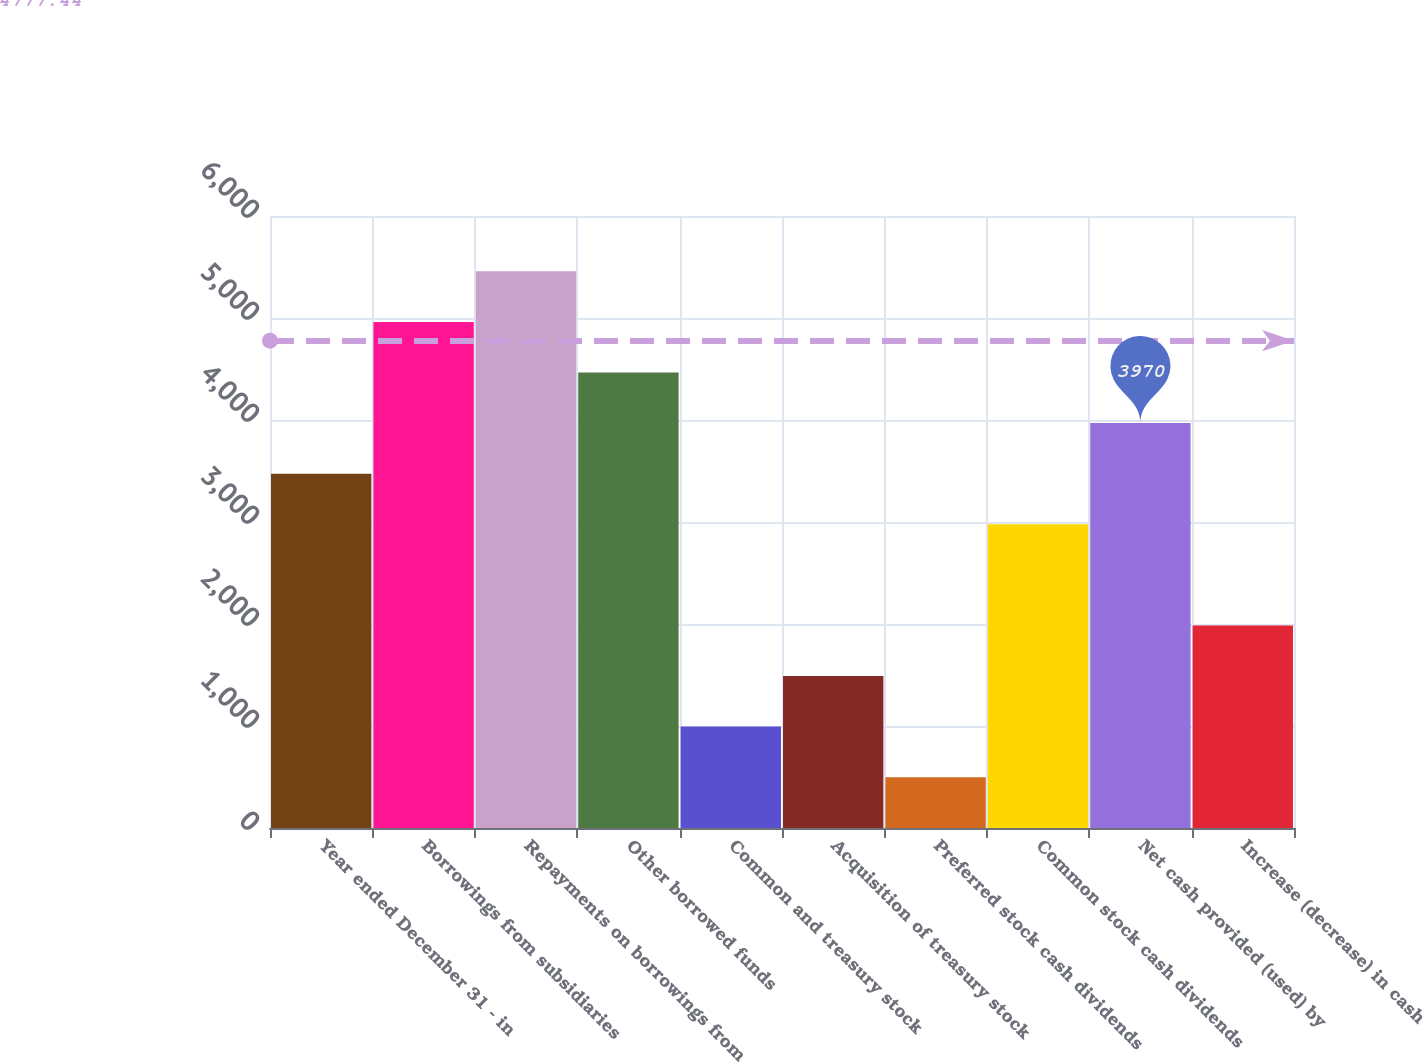<chart> <loc_0><loc_0><loc_500><loc_500><bar_chart><fcel>Year ended December 31 - in<fcel>Borrowings from subsidiaries<fcel>Repayments on borrowings from<fcel>Other borrowed funds<fcel>Common and treasury stock<fcel>Acquisition of treasury stock<fcel>Preferred stock cash dividends<fcel>Common stock cash dividends<fcel>Net cash provided (used) by<fcel>Increase (decrease) in cash<nl><fcel>3474<fcel>4962<fcel>5458<fcel>4466<fcel>994<fcel>1490<fcel>498<fcel>2978<fcel>3970<fcel>1986<nl></chart> 